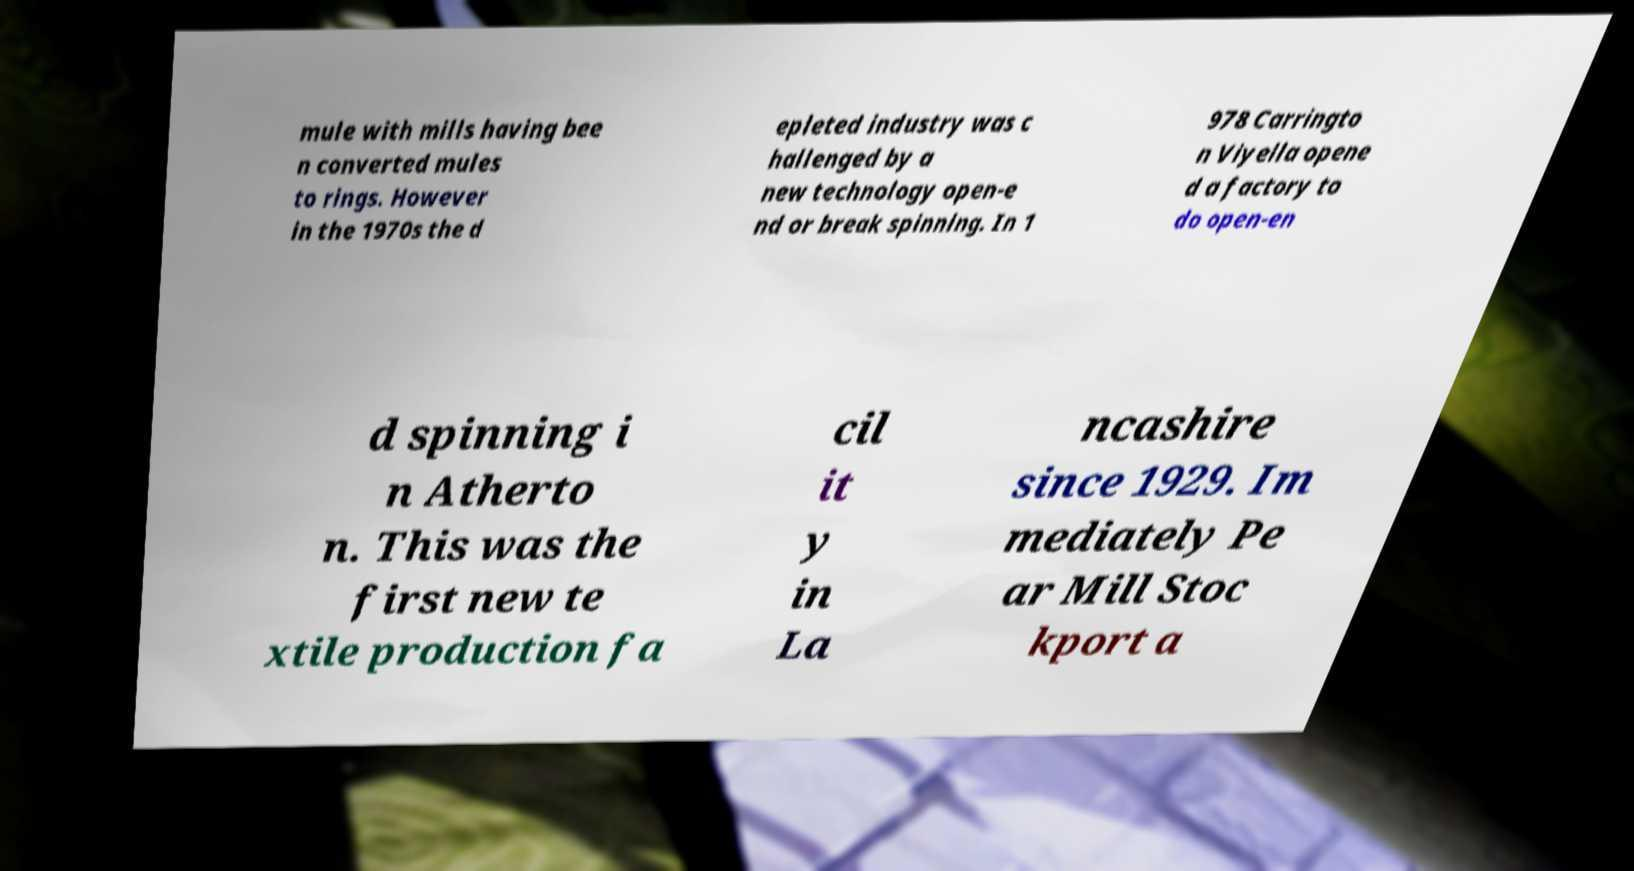Can you accurately transcribe the text from the provided image for me? mule with mills having bee n converted mules to rings. However in the 1970s the d epleted industry was c hallenged by a new technology open-e nd or break spinning. In 1 978 Carringto n Viyella opene d a factory to do open-en d spinning i n Atherto n. This was the first new te xtile production fa cil it y in La ncashire since 1929. Im mediately Pe ar Mill Stoc kport a 